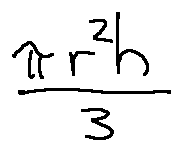Convert formula to latex. <formula><loc_0><loc_0><loc_500><loc_500>\frac { \pi r ^ { 2 } h } { 3 }</formula> 